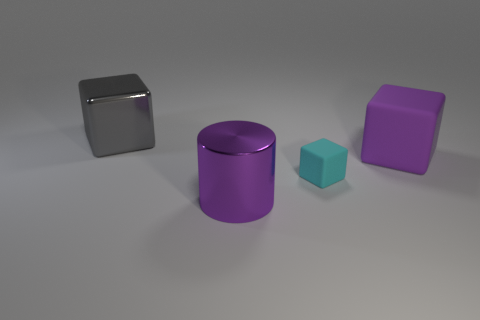Is there any other thing that has the same size as the cyan rubber thing?
Offer a terse response. No. How many tiny objects are either cyan cubes or gray metallic objects?
Your answer should be compact. 1. Is there any other thing that is the same color as the large matte object?
Keep it short and to the point. Yes. There is another big object that is the same material as the cyan thing; what is its shape?
Give a very brief answer. Cube. What is the size of the shiny object in front of the gray shiny block?
Give a very brief answer. Large. What is the shape of the big purple shiny thing?
Your response must be concise. Cylinder. Do the object that is in front of the cyan matte cube and the matte block that is on the right side of the small thing have the same size?
Provide a short and direct response. Yes. There is a metallic object that is in front of the cube that is in front of the big purple thing that is behind the big metallic cylinder; how big is it?
Provide a short and direct response. Large. What shape is the big metallic object that is behind the large cube in front of the cube behind the big purple block?
Keep it short and to the point. Cube. The large metal thing that is behind the purple cylinder has what shape?
Give a very brief answer. Cube. 